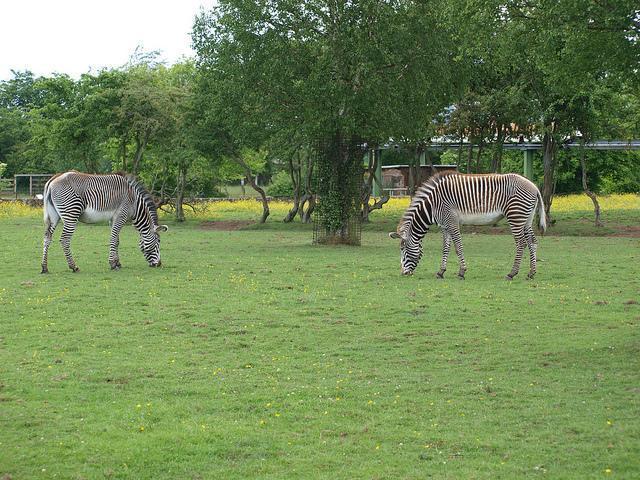How many zebras are in this photo?
Give a very brief answer. 2. How many zebras are there?
Give a very brief answer. 2. How many plates with cake are shown in this picture?
Give a very brief answer. 0. 